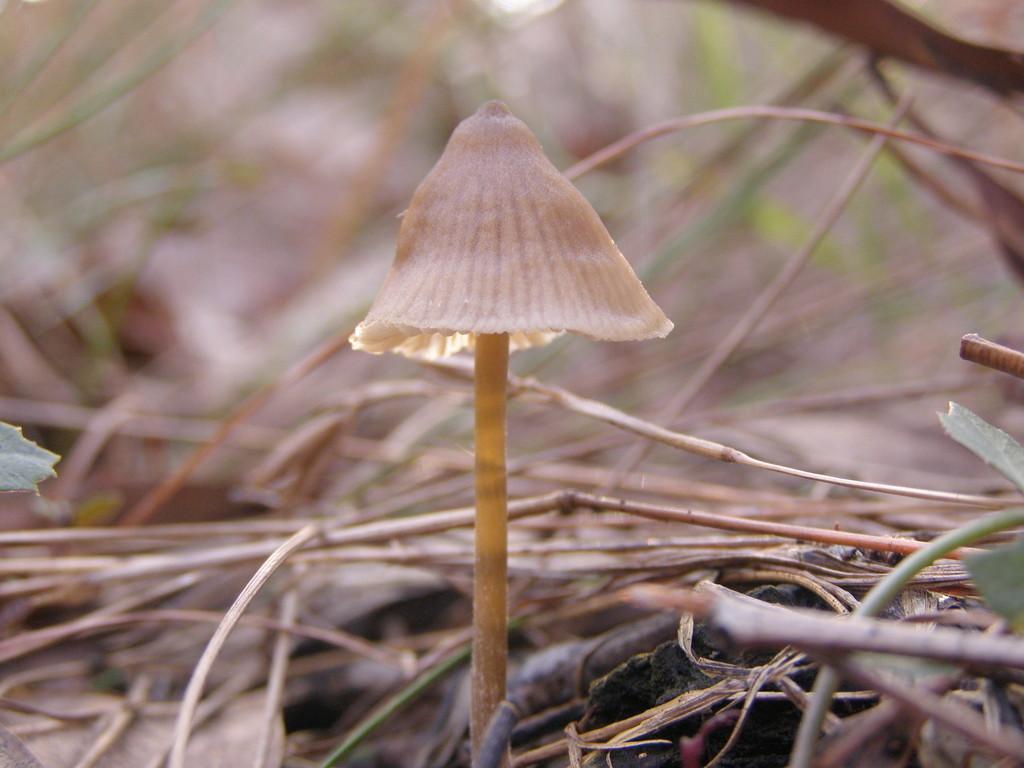In one or two sentences, can you explain what this image depicts? In the center of the picture there is a mushroom, beside the mushroom there are twigs and leaves. The background is blurred. 